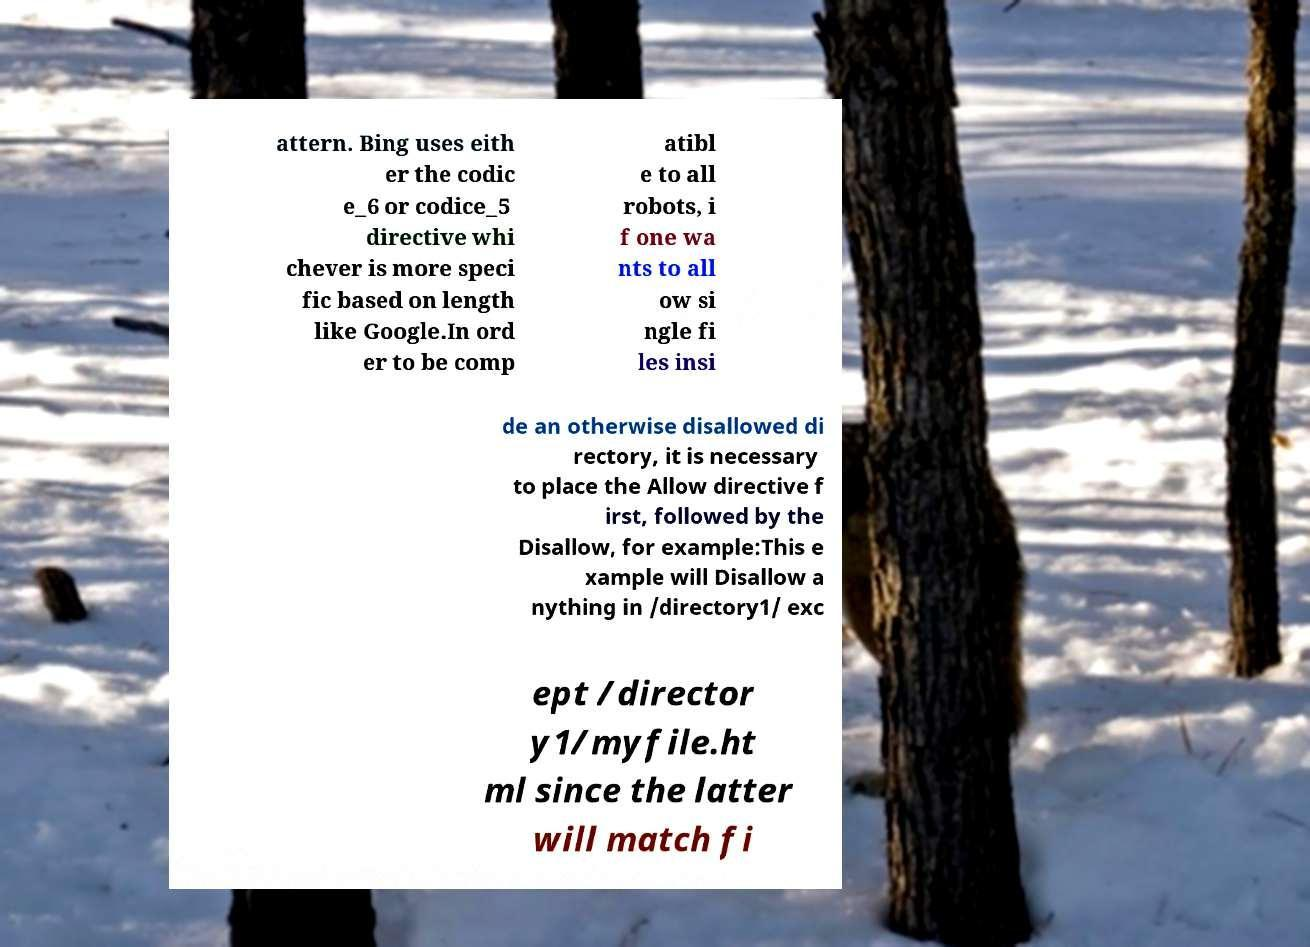There's text embedded in this image that I need extracted. Can you transcribe it verbatim? attern. Bing uses eith er the codic e_6 or codice_5 directive whi chever is more speci fic based on length like Google.In ord er to be comp atibl e to all robots, i f one wa nts to all ow si ngle fi les insi de an otherwise disallowed di rectory, it is necessary to place the Allow directive f irst, followed by the Disallow, for example:This e xample will Disallow a nything in /directory1/ exc ept /director y1/myfile.ht ml since the latter will match fi 